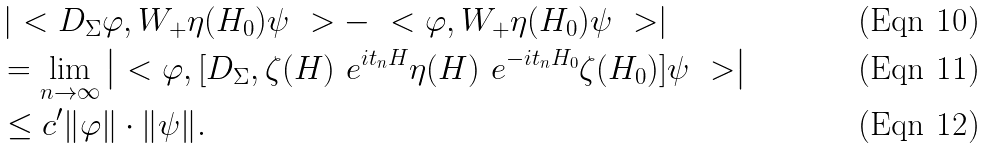<formula> <loc_0><loc_0><loc_500><loc_500>& \left | \ < D _ { \Sigma } \varphi , W _ { + } \eta ( H _ { 0 } ) \psi \ > - \ < \varphi , W _ { + } \eta ( H _ { 0 } ) \psi \ > \right | \\ & = \lim _ { n \to \infty } \left | \ < \varphi , [ D _ { \Sigma } , \zeta ( H ) \ e ^ { i t _ { n } H } \eta ( H ) \ e ^ { - i t _ { n } H _ { 0 } } \zeta ( H _ { 0 } ) ] \psi \ > \right | \\ & \leq c ^ { \prime } \| \varphi \| \cdot \| \psi \| .</formula> 